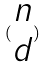Convert formula to latex. <formula><loc_0><loc_0><loc_500><loc_500>( \begin{matrix} n \\ d \end{matrix} )</formula> 